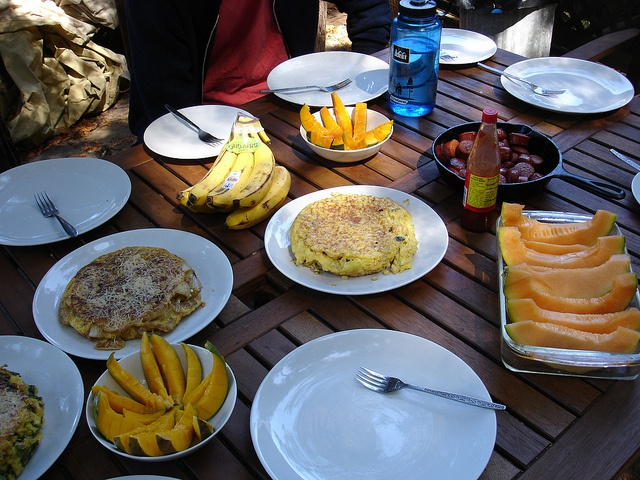Describe the objects in this image and their specific colors. I can see dining table in lightgray, black, lightblue, and gray tones, bowl in lightgray, olive, black, and gray tones, people in lightgray, black, gray, and maroon tones, pizza in lightgray, gray, olive, maroon, and black tones, and banana in lightgray, khaki, black, and tan tones in this image. 